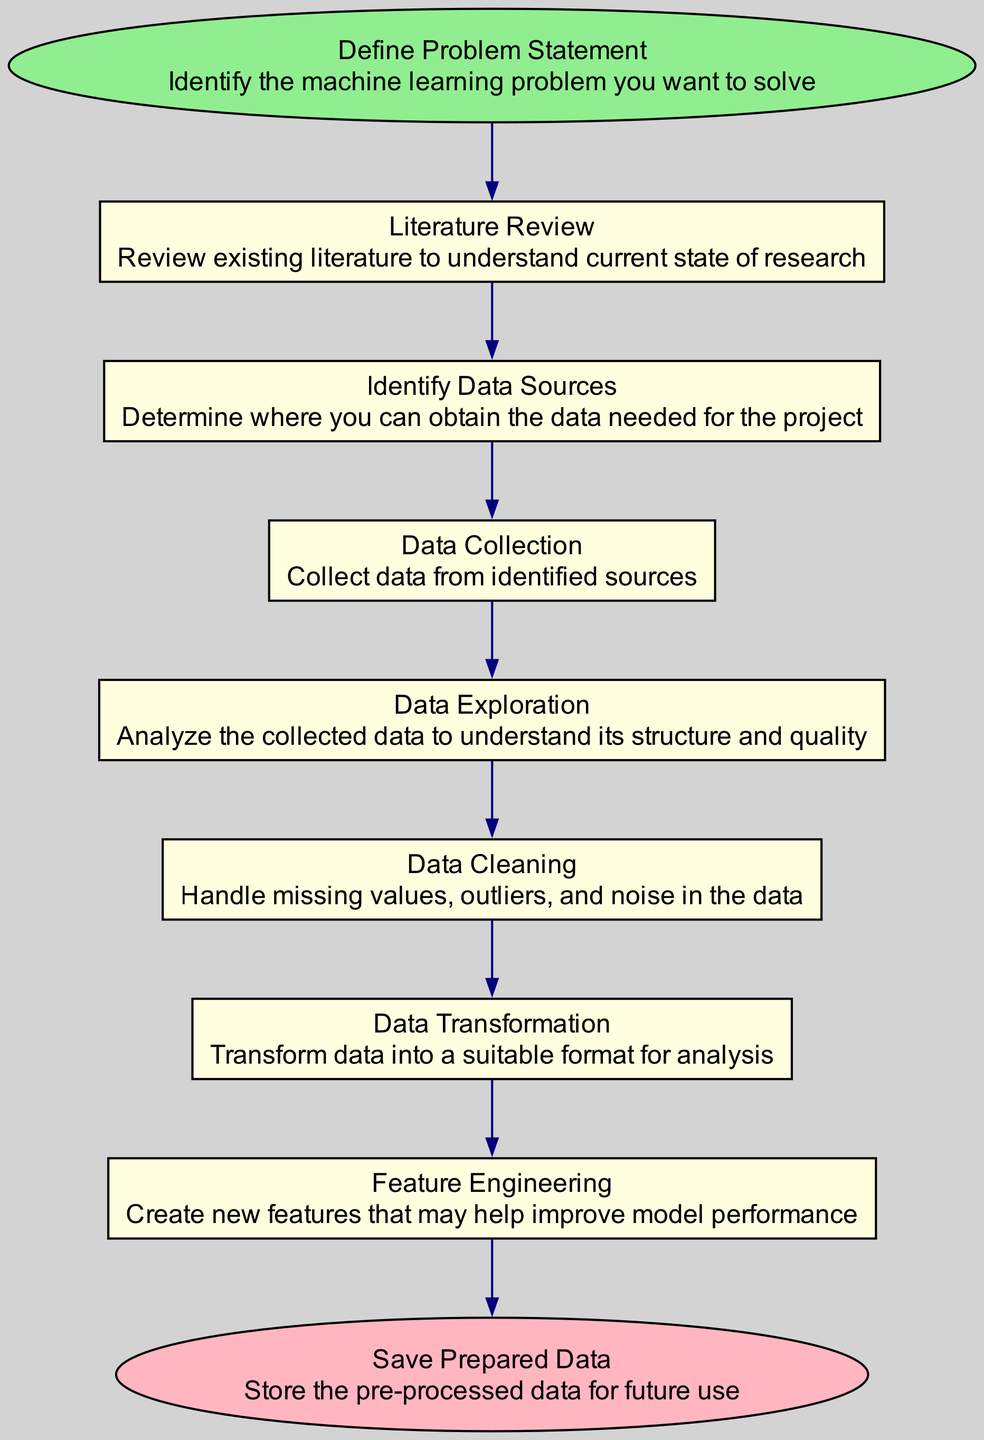What is the first step in the diagram? The first step is identified as the "Define Problem Statement," as it is classified as the starting activity in the diagram.
Answer: Define Problem Statement How many activities are shown in the diagram? The diagram contains a total of eight activities, which can be counted directly from the list provided in the data.
Answer: Eight What is the last activity before saving prepared data? The last activity before saving is "Feature Engineering," which leads directly to the "Save Prepared Data" step in the sequence.
Answer: Feature Engineering Which activities are preceded by data exploration? Data Cleaning is the activity that directly follows Data Exploration, as indicated in the flow of transitions between activities in the diagram.
Answer: Data Cleaning What type of node represents "Save Prepared Data"? "Save Prepared Data" is represented as an end node, since it indicates the completion of the process and is visually distinguished as an end type in the diagram.
Answer: End How does the process flow start? The flow starts from the "Define Problem Statement" node, which indicates that problem identification is the first necessary step before progressing to the next activity.
Answer: Define Problem Statement What type of process does data collection belong to? Data Collection is categorized as an activity within the overall sequence of steps for collecting and pre-processing data for a machine learning model.
Answer: Activity What is the main purpose of the "Data Cleaning" stage? The main purpose of the Data Cleaning stage is to handle issues like missing values, outliers, and noise in the data, ensuring the data's quality before proceeding to transformation.
Answer: Handle missing values, outliers, and noise Which activity comes after "Data Transformation"? The activity that follows "Data Transformation" is "Feature Engineering," which involves creating new features that may enhance model performance.
Answer: Feature Engineering 